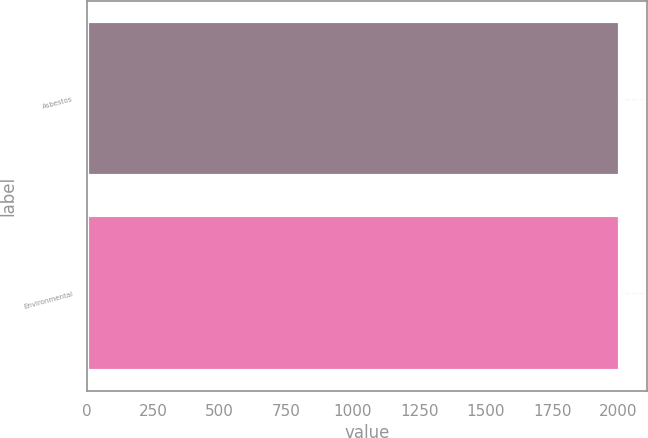Convert chart. <chart><loc_0><loc_0><loc_500><loc_500><bar_chart><fcel>Asbestos<fcel>Environmental<nl><fcel>2007<fcel>2007.1<nl></chart> 